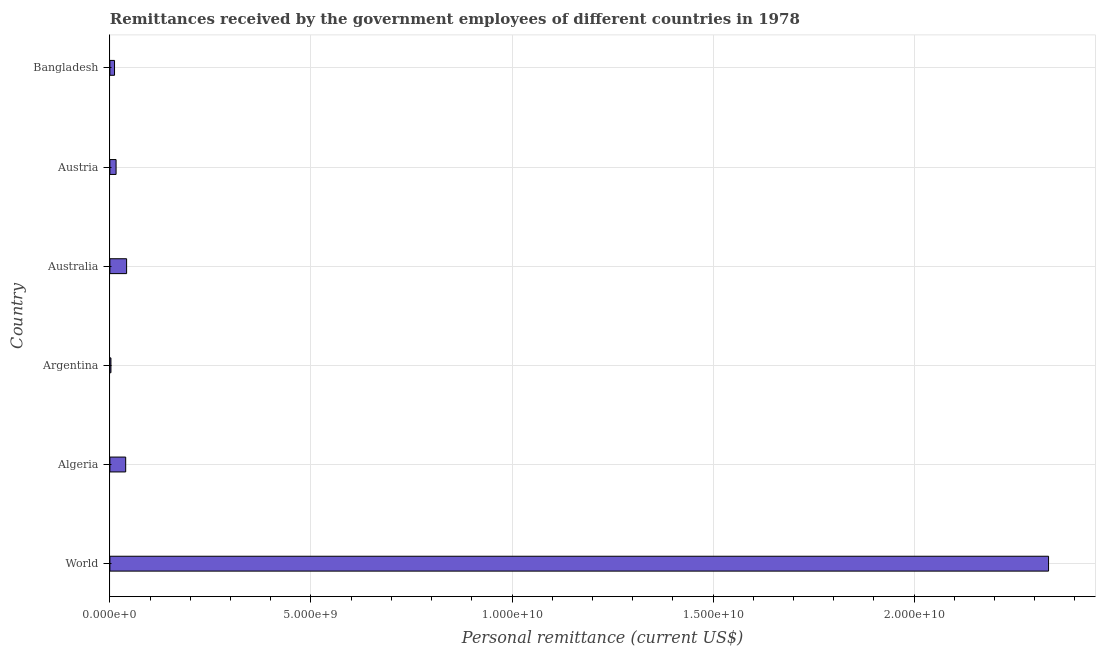Does the graph contain any zero values?
Provide a succinct answer. No. What is the title of the graph?
Provide a short and direct response. Remittances received by the government employees of different countries in 1978. What is the label or title of the X-axis?
Offer a very short reply. Personal remittance (current US$). What is the personal remittances in Austria?
Offer a very short reply. 1.54e+08. Across all countries, what is the maximum personal remittances?
Your answer should be very brief. 2.33e+1. Across all countries, what is the minimum personal remittances?
Your response must be concise. 2.60e+07. In which country was the personal remittances maximum?
Ensure brevity in your answer.  World. In which country was the personal remittances minimum?
Ensure brevity in your answer.  Argentina. What is the sum of the personal remittances?
Your answer should be compact. 2.44e+1. What is the difference between the personal remittances in Australia and Bangladesh?
Your response must be concise. 3.00e+08. What is the average personal remittances per country?
Keep it short and to the point. 4.07e+09. What is the median personal remittances?
Provide a succinct answer. 2.74e+08. In how many countries, is the personal remittances greater than 7000000000 US$?
Your answer should be very brief. 1. What is the ratio of the personal remittances in Algeria to that in Argentina?
Offer a very short reply. 15.12. Is the personal remittances in Austria less than that in World?
Your response must be concise. Yes. What is the difference between the highest and the second highest personal remittances?
Provide a succinct answer. 2.29e+1. Is the sum of the personal remittances in Algeria and Austria greater than the maximum personal remittances across all countries?
Your answer should be compact. No. What is the difference between the highest and the lowest personal remittances?
Ensure brevity in your answer.  2.33e+1. In how many countries, is the personal remittances greater than the average personal remittances taken over all countries?
Your answer should be very brief. 1. Are all the bars in the graph horizontal?
Ensure brevity in your answer.  Yes. How many countries are there in the graph?
Offer a very short reply. 6. What is the difference between two consecutive major ticks on the X-axis?
Your answer should be compact. 5.00e+09. What is the Personal remittance (current US$) of World?
Provide a succinct answer. 2.33e+1. What is the Personal remittance (current US$) in Algeria?
Make the answer very short. 3.93e+08. What is the Personal remittance (current US$) in Argentina?
Offer a very short reply. 2.60e+07. What is the Personal remittance (current US$) in Australia?
Offer a terse response. 4.16e+08. What is the Personal remittance (current US$) in Austria?
Provide a succinct answer. 1.54e+08. What is the Personal remittance (current US$) of Bangladesh?
Give a very brief answer. 1.15e+08. What is the difference between the Personal remittance (current US$) in World and Algeria?
Provide a short and direct response. 2.29e+1. What is the difference between the Personal remittance (current US$) in World and Argentina?
Your answer should be compact. 2.33e+1. What is the difference between the Personal remittance (current US$) in World and Australia?
Provide a short and direct response. 2.29e+1. What is the difference between the Personal remittance (current US$) in World and Austria?
Provide a short and direct response. 2.32e+1. What is the difference between the Personal remittance (current US$) in World and Bangladesh?
Your answer should be compact. 2.32e+1. What is the difference between the Personal remittance (current US$) in Algeria and Argentina?
Provide a succinct answer. 3.67e+08. What is the difference between the Personal remittance (current US$) in Algeria and Australia?
Make the answer very short. -2.26e+07. What is the difference between the Personal remittance (current US$) in Algeria and Austria?
Your answer should be very brief. 2.39e+08. What is the difference between the Personal remittance (current US$) in Algeria and Bangladesh?
Ensure brevity in your answer.  2.78e+08. What is the difference between the Personal remittance (current US$) in Argentina and Australia?
Your answer should be compact. -3.90e+08. What is the difference between the Personal remittance (current US$) in Argentina and Austria?
Your answer should be very brief. -1.28e+08. What is the difference between the Personal remittance (current US$) in Argentina and Bangladesh?
Provide a short and direct response. -8.94e+07. What is the difference between the Personal remittance (current US$) in Australia and Austria?
Give a very brief answer. 2.62e+08. What is the difference between the Personal remittance (current US$) in Australia and Bangladesh?
Provide a short and direct response. 3.00e+08. What is the difference between the Personal remittance (current US$) in Austria and Bangladesh?
Provide a short and direct response. 3.86e+07. What is the ratio of the Personal remittance (current US$) in World to that in Algeria?
Your response must be concise. 59.4. What is the ratio of the Personal remittance (current US$) in World to that in Argentina?
Offer a very short reply. 897.8. What is the ratio of the Personal remittance (current US$) in World to that in Australia?
Provide a succinct answer. 56.16. What is the ratio of the Personal remittance (current US$) in World to that in Austria?
Ensure brevity in your answer.  151.55. What is the ratio of the Personal remittance (current US$) in World to that in Bangladesh?
Your answer should be compact. 202.22. What is the ratio of the Personal remittance (current US$) in Algeria to that in Argentina?
Provide a succinct answer. 15.12. What is the ratio of the Personal remittance (current US$) in Algeria to that in Australia?
Provide a short and direct response. 0.95. What is the ratio of the Personal remittance (current US$) in Algeria to that in Austria?
Your answer should be very brief. 2.55. What is the ratio of the Personal remittance (current US$) in Algeria to that in Bangladesh?
Your response must be concise. 3.4. What is the ratio of the Personal remittance (current US$) in Argentina to that in Australia?
Your answer should be compact. 0.06. What is the ratio of the Personal remittance (current US$) in Argentina to that in Austria?
Ensure brevity in your answer.  0.17. What is the ratio of the Personal remittance (current US$) in Argentina to that in Bangladesh?
Provide a succinct answer. 0.23. What is the ratio of the Personal remittance (current US$) in Australia to that in Austria?
Your answer should be very brief. 2.7. What is the ratio of the Personal remittance (current US$) in Australia to that in Bangladesh?
Offer a very short reply. 3.6. What is the ratio of the Personal remittance (current US$) in Austria to that in Bangladesh?
Keep it short and to the point. 1.33. 